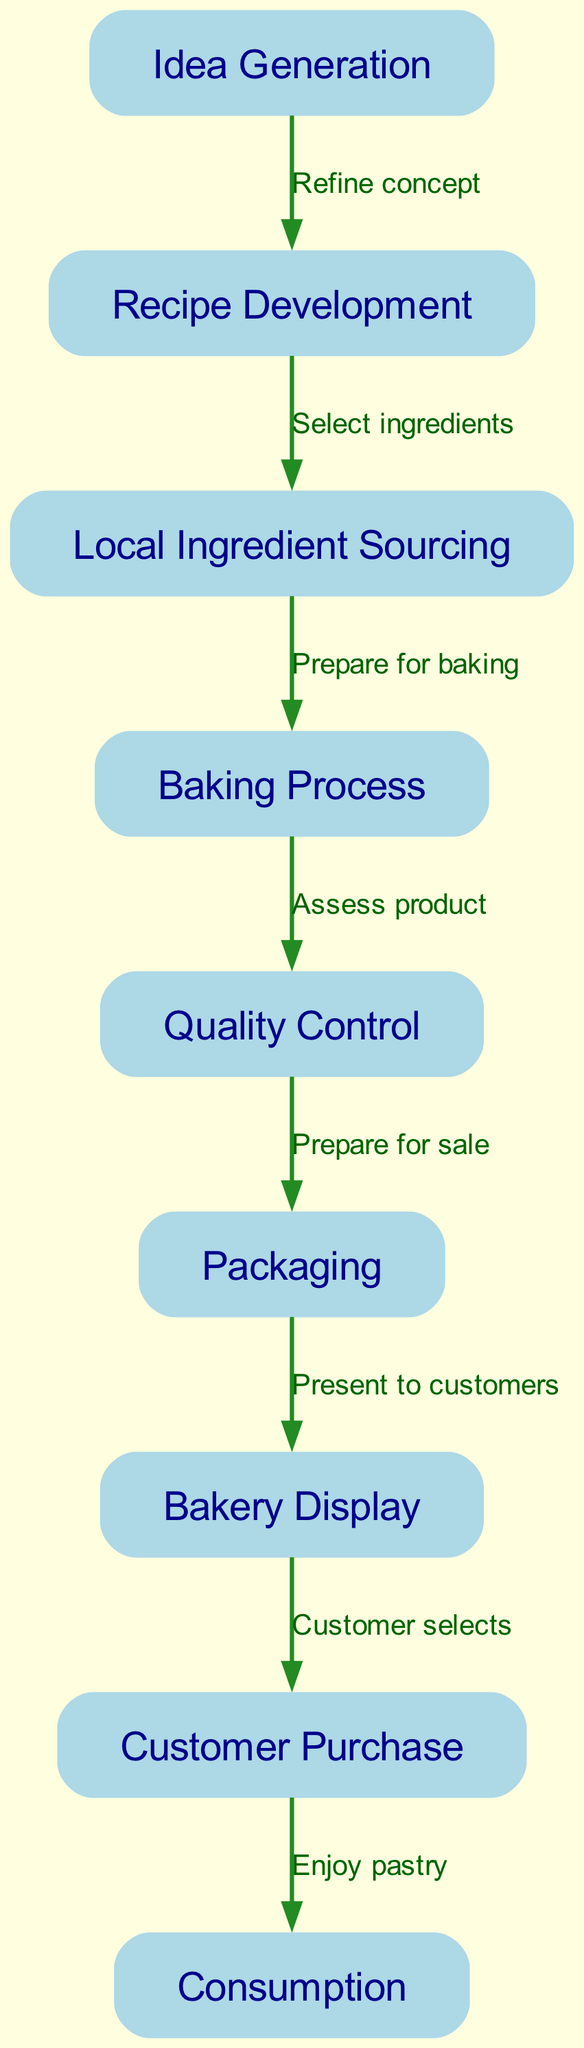What is the first step in the pastry lifecycle? The diagram indicates that the first step is "Idea Generation," which is labeled as node 1 in the diagram.
Answer: Idea Generation How many nodes are involved in the pastry lifecycle? The diagram lists a total of nine nodes, each representing a different stage in the lifecycle, from concept to consumption.
Answer: Nine What is the relationship between Recipe Development and Local Ingredient Sourcing? The edge between node 2 (Recipe Development) and node 3 (Local Ingredient Sourcing) shows the label "Select ingredients," indicating the action taken in this relationship.
Answer: Select ingredients What step follows the Baking Process? Referring to the diagram, the step that follows "Baking Process," which is node 4, is "Quality Control," as indicated by the directed edge between these two nodes.
Answer: Quality Control Which node represents the final action in consuming the pastry? The last action in the diagram is represented by node 9, which is labeled "Consumption." The progression leads to this final step after the customer purchase.
Answer: Consumption What is the third step in the lifecycle? Analyzing the flow of the diagram, the third step is "Local Ingredient Sourcing," which is node 3, following "Idea Generation" and "Recipe Development."
Answer: Local Ingredient Sourcing How does Quality Control relate to Packaging? The diagram shows an edge from "Quality Control" (node 5) to "Packaging" (node 6) labeled "Prepare for sale," indicating that quality control is a precursor to packaging the product for sale.
Answer: Prepare for sale Which node directly follows Bakery Display? Looking at the diagram, "Customer Purchase" (node 8) directly follows "Bakery Display" (node 7), as indicated by the connection between these two nodes.
Answer: Customer Purchase What action precedes the baking process? The action that precedes the "Baking Process" (node 4) is "Local Ingredient Sourcing," which is represented by node 3, showing the sequence in the flow of steps.
Answer: Local Ingredient Sourcing 